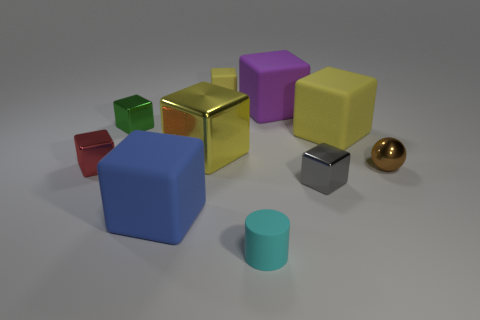There is a big matte block that is on the right side of the small gray metallic thing; how many yellow rubber blocks are to the left of it?
Offer a terse response. 1. Does the big blue block that is to the left of the big yellow shiny thing have the same material as the small cube in front of the red cube?
Ensure brevity in your answer.  No. How many purple things are the same shape as the cyan rubber object?
Offer a terse response. 0. What number of objects have the same color as the big shiny block?
Provide a short and direct response. 2. Does the green shiny object that is behind the small gray metallic block have the same shape as the yellow metal object that is behind the tiny red metal block?
Offer a terse response. Yes. There is a yellow object that is behind the yellow thing that is to the right of the small cylinder; how many matte objects are left of it?
Offer a terse response. 1. What material is the small green object that is behind the yellow thing to the right of the tiny yellow cube that is left of the cyan rubber thing?
Ensure brevity in your answer.  Metal. Is the material of the big cube behind the tiny green shiny cube the same as the small green cube?
Your answer should be compact. No. What number of gray cubes are the same size as the red object?
Your answer should be very brief. 1. Is the number of yellow cubes left of the gray block greater than the number of big blue things to the left of the red metal cube?
Make the answer very short. Yes. 